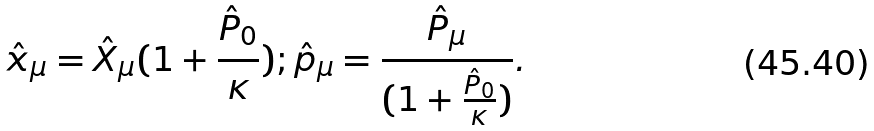<formula> <loc_0><loc_0><loc_500><loc_500>\hat { x } _ { \mu } = \hat { X } _ { \mu } ( 1 + \frac { \hat { P } _ { 0 } } { \kappa } ) ; \hat { p } _ { \mu } = \frac { \hat { P } _ { \mu } } { ( 1 + \frac { \hat { P } _ { 0 } } { \kappa } ) } .</formula> 